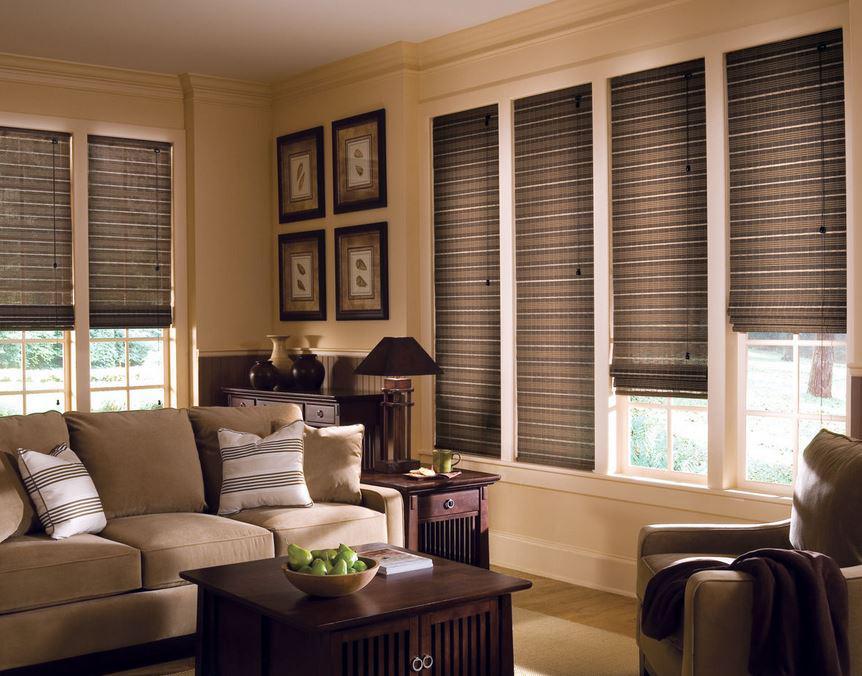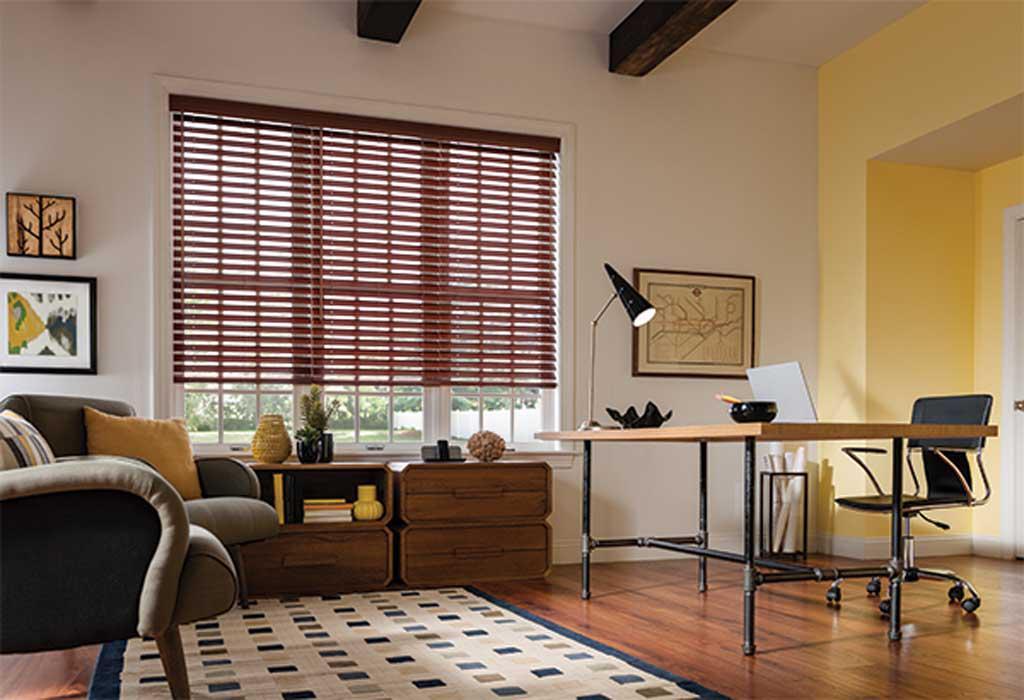The first image is the image on the left, the second image is the image on the right. Assess this claim about the two images: "There are a total of six blinds.". Correct or not? Answer yes or no. No. 